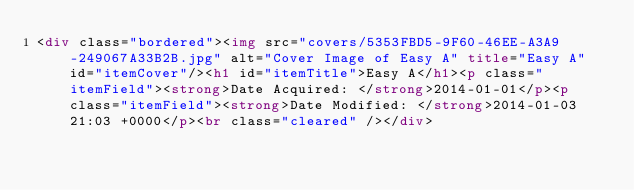<code> <loc_0><loc_0><loc_500><loc_500><_HTML_><div class="bordered"><img src="covers/5353FBD5-9F60-46EE-A3A9-249067A33B2B.jpg" alt="Cover Image of Easy A" title="Easy A" id="itemCover"/><h1 id="itemTitle">Easy A</h1><p class="itemField"><strong>Date Acquired: </strong>2014-01-01</p><p class="itemField"><strong>Date Modified: </strong>2014-01-03 21:03 +0000</p><br class="cleared" /></div></code> 